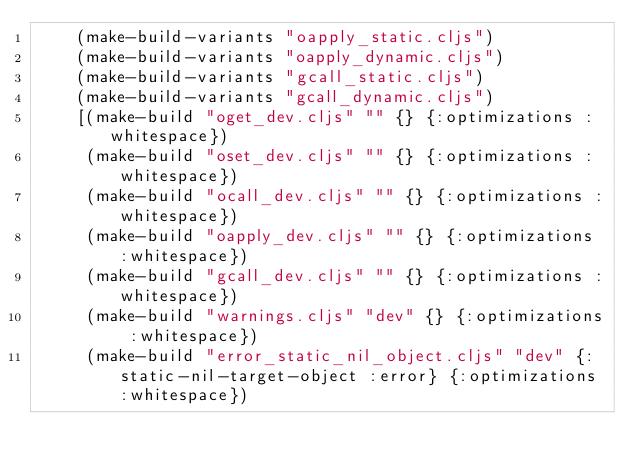Convert code to text. <code><loc_0><loc_0><loc_500><loc_500><_Clojure_>    (make-build-variants "oapply_static.cljs")
    (make-build-variants "oapply_dynamic.cljs")
    (make-build-variants "gcall_static.cljs")
    (make-build-variants "gcall_dynamic.cljs")
    [(make-build "oget_dev.cljs" "" {} {:optimizations :whitespace})
     (make-build "oset_dev.cljs" "" {} {:optimizations :whitespace})
     (make-build "ocall_dev.cljs" "" {} {:optimizations :whitespace})
     (make-build "oapply_dev.cljs" "" {} {:optimizations :whitespace})
     (make-build "gcall_dev.cljs" "" {} {:optimizations :whitespace})
     (make-build "warnings.cljs" "dev" {} {:optimizations :whitespace})
     (make-build "error_static_nil_object.cljs" "dev" {:static-nil-target-object :error} {:optimizations :whitespace})</code> 